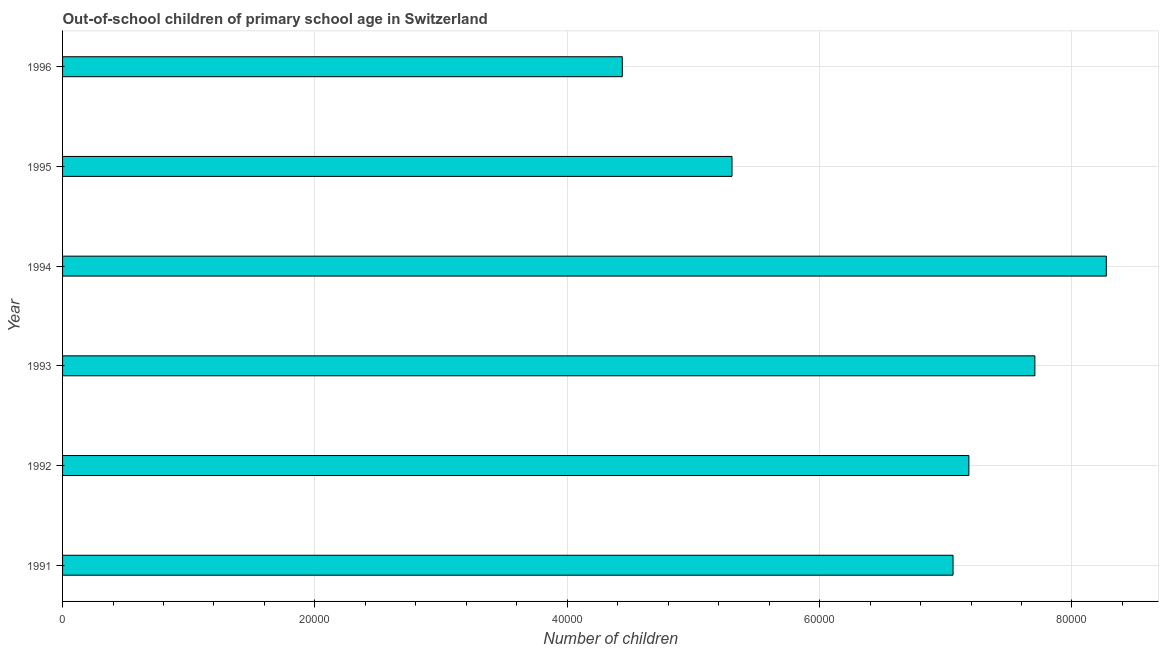What is the title of the graph?
Ensure brevity in your answer.  Out-of-school children of primary school age in Switzerland. What is the label or title of the X-axis?
Give a very brief answer. Number of children. What is the number of out-of-school children in 1995?
Offer a very short reply. 5.31e+04. Across all years, what is the maximum number of out-of-school children?
Your answer should be compact. 8.27e+04. Across all years, what is the minimum number of out-of-school children?
Ensure brevity in your answer.  4.44e+04. In which year was the number of out-of-school children maximum?
Give a very brief answer. 1994. What is the sum of the number of out-of-school children?
Make the answer very short. 4.00e+05. What is the difference between the number of out-of-school children in 1991 and 1996?
Give a very brief answer. 2.62e+04. What is the average number of out-of-school children per year?
Your answer should be compact. 6.66e+04. What is the median number of out-of-school children?
Ensure brevity in your answer.  7.12e+04. Do a majority of the years between 1993 and 1996 (inclusive) have number of out-of-school children greater than 8000 ?
Your response must be concise. Yes. What is the ratio of the number of out-of-school children in 1994 to that in 1996?
Your response must be concise. 1.86. Is the number of out-of-school children in 1995 less than that in 1996?
Make the answer very short. No. What is the difference between the highest and the second highest number of out-of-school children?
Your response must be concise. 5661. Is the sum of the number of out-of-school children in 1991 and 1995 greater than the maximum number of out-of-school children across all years?
Keep it short and to the point. Yes. What is the difference between the highest and the lowest number of out-of-school children?
Offer a very short reply. 3.84e+04. In how many years, is the number of out-of-school children greater than the average number of out-of-school children taken over all years?
Keep it short and to the point. 4. Are all the bars in the graph horizontal?
Your answer should be compact. Yes. Are the values on the major ticks of X-axis written in scientific E-notation?
Your answer should be very brief. No. What is the Number of children in 1991?
Keep it short and to the point. 7.06e+04. What is the Number of children of 1992?
Your answer should be compact. 7.18e+04. What is the Number of children of 1993?
Offer a terse response. 7.71e+04. What is the Number of children of 1994?
Make the answer very short. 8.27e+04. What is the Number of children of 1995?
Your answer should be very brief. 5.31e+04. What is the Number of children in 1996?
Keep it short and to the point. 4.44e+04. What is the difference between the Number of children in 1991 and 1992?
Keep it short and to the point. -1254. What is the difference between the Number of children in 1991 and 1993?
Provide a succinct answer. -6486. What is the difference between the Number of children in 1991 and 1994?
Provide a short and direct response. -1.21e+04. What is the difference between the Number of children in 1991 and 1995?
Offer a terse response. 1.75e+04. What is the difference between the Number of children in 1991 and 1996?
Give a very brief answer. 2.62e+04. What is the difference between the Number of children in 1992 and 1993?
Offer a very short reply. -5232. What is the difference between the Number of children in 1992 and 1994?
Give a very brief answer. -1.09e+04. What is the difference between the Number of children in 1992 and 1995?
Make the answer very short. 1.88e+04. What is the difference between the Number of children in 1992 and 1996?
Your response must be concise. 2.75e+04. What is the difference between the Number of children in 1993 and 1994?
Keep it short and to the point. -5661. What is the difference between the Number of children in 1993 and 1995?
Keep it short and to the point. 2.40e+04. What is the difference between the Number of children in 1993 and 1996?
Your answer should be compact. 3.27e+04. What is the difference between the Number of children in 1994 and 1995?
Your answer should be compact. 2.97e+04. What is the difference between the Number of children in 1994 and 1996?
Ensure brevity in your answer.  3.84e+04. What is the difference between the Number of children in 1995 and 1996?
Give a very brief answer. 8693. What is the ratio of the Number of children in 1991 to that in 1993?
Provide a short and direct response. 0.92. What is the ratio of the Number of children in 1991 to that in 1994?
Ensure brevity in your answer.  0.85. What is the ratio of the Number of children in 1991 to that in 1995?
Provide a succinct answer. 1.33. What is the ratio of the Number of children in 1991 to that in 1996?
Keep it short and to the point. 1.59. What is the ratio of the Number of children in 1992 to that in 1993?
Your answer should be compact. 0.93. What is the ratio of the Number of children in 1992 to that in 1994?
Your answer should be compact. 0.87. What is the ratio of the Number of children in 1992 to that in 1995?
Your answer should be compact. 1.35. What is the ratio of the Number of children in 1992 to that in 1996?
Provide a succinct answer. 1.62. What is the ratio of the Number of children in 1993 to that in 1994?
Your response must be concise. 0.93. What is the ratio of the Number of children in 1993 to that in 1995?
Provide a short and direct response. 1.45. What is the ratio of the Number of children in 1993 to that in 1996?
Your answer should be very brief. 1.74. What is the ratio of the Number of children in 1994 to that in 1995?
Ensure brevity in your answer.  1.56. What is the ratio of the Number of children in 1994 to that in 1996?
Your response must be concise. 1.86. What is the ratio of the Number of children in 1995 to that in 1996?
Your response must be concise. 1.2. 